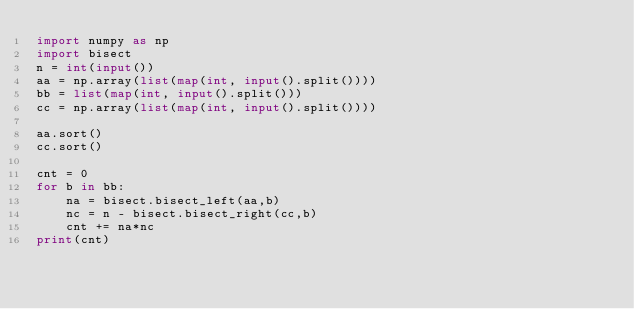Convert code to text. <code><loc_0><loc_0><loc_500><loc_500><_Python_>import numpy as np
import bisect
n = int(input())
aa = np.array(list(map(int, input().split())))
bb = list(map(int, input().split()))
cc = np.array(list(map(int, input().split())))

aa.sort()
cc.sort()

cnt = 0
for b in bb:
    na = bisect.bisect_left(aa,b)
    nc = n - bisect.bisect_right(cc,b)
    cnt += na*nc
print(cnt)</code> 